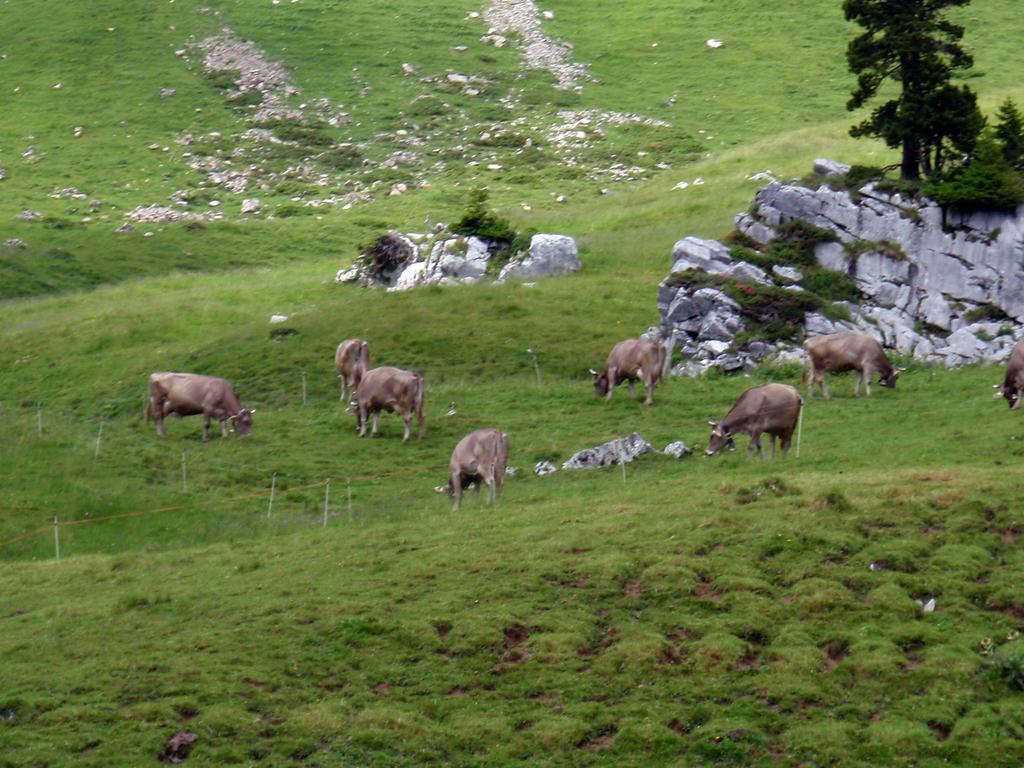What types of living organisms can be seen in the image? There are animals in the image. What natural elements are present in the image? There are trees, rocks, and grass in the image. What type of flowers can be seen growing near the girl in the image? There is no girl present in the image, and therefore no flowers can be seen growing near her. 